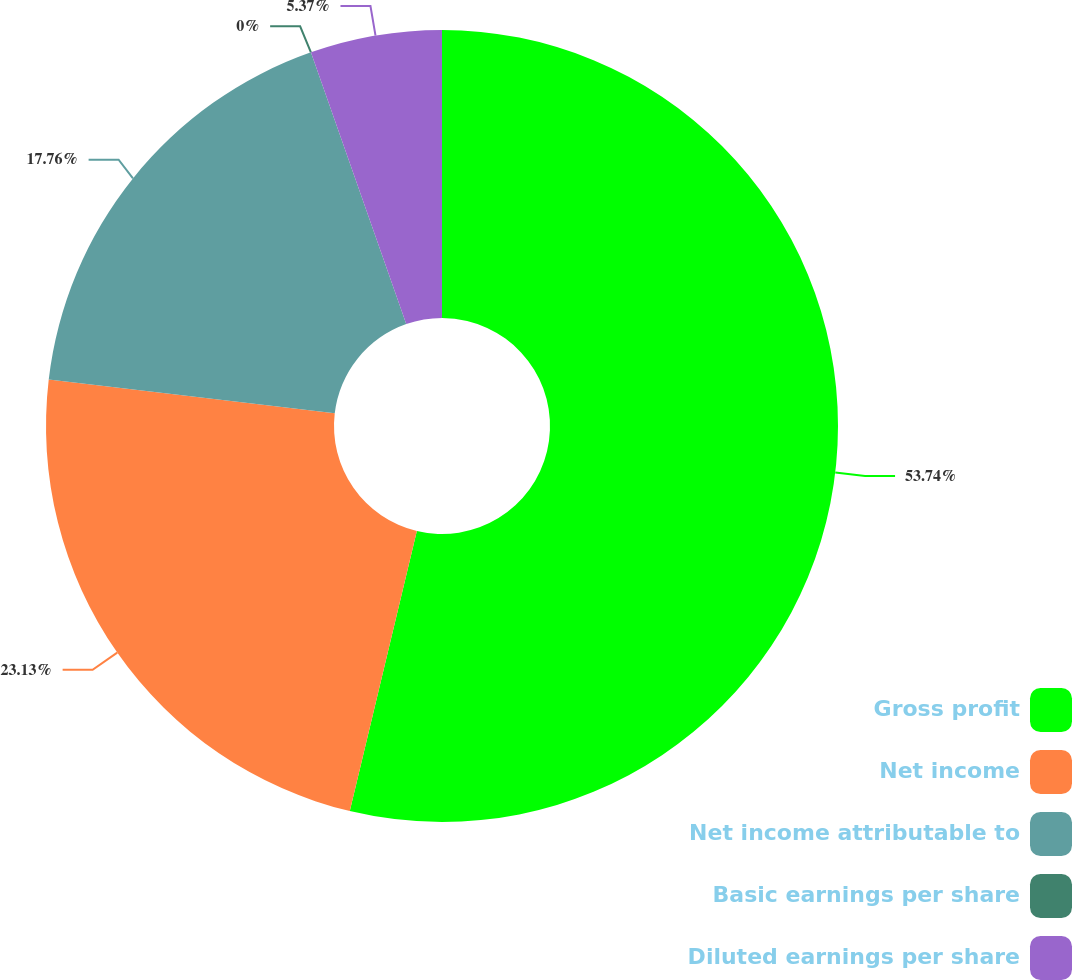<chart> <loc_0><loc_0><loc_500><loc_500><pie_chart><fcel>Gross profit<fcel>Net income<fcel>Net income attributable to<fcel>Basic earnings per share<fcel>Diluted earnings per share<nl><fcel>53.74%<fcel>23.13%<fcel>17.76%<fcel>0.0%<fcel>5.37%<nl></chart> 